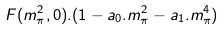<formula> <loc_0><loc_0><loc_500><loc_500>F ( m _ { \pi } ^ { 2 } , 0 ) . ( 1 - a _ { 0 } . m _ { \pi } ^ { 2 } - a _ { 1 } . m _ { \pi } ^ { 4 } )</formula> 